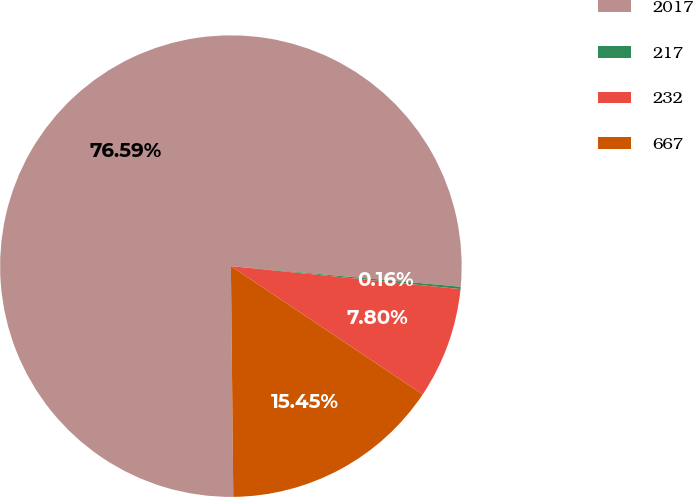Convert chart to OTSL. <chart><loc_0><loc_0><loc_500><loc_500><pie_chart><fcel>2017<fcel>217<fcel>232<fcel>667<nl><fcel>76.6%<fcel>0.16%<fcel>7.8%<fcel>15.45%<nl></chart> 